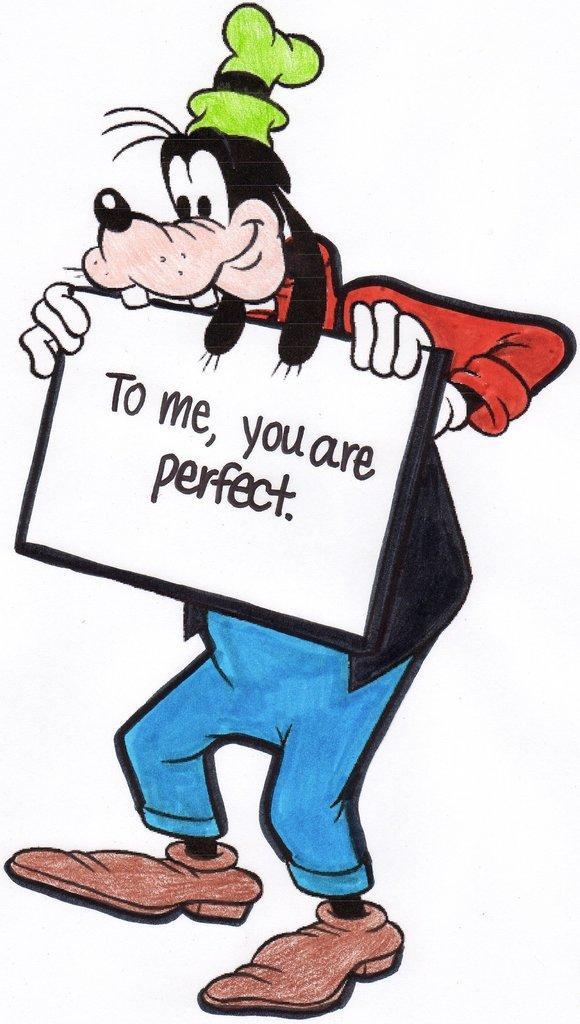Could you give a brief overview of what you see in this image? In the middle of the image we can see a cartoon image and we can see some text. 